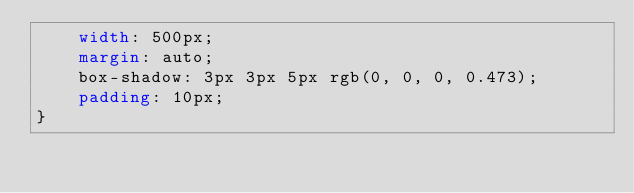Convert code to text. <code><loc_0><loc_0><loc_500><loc_500><_CSS_>    width: 500px;
    margin: auto;
    box-shadow: 3px 3px 5px rgb(0, 0, 0, 0.473);
    padding: 10px;
}</code> 